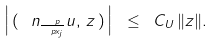<formula> <loc_0><loc_0><loc_500><loc_500>\left | \, ( \, \ n _ { \frac { \ p } { \ p x _ { j } } } u , \, z \, ) \, \right | \ \leq \ C _ { U } \, \| z \| .</formula> 